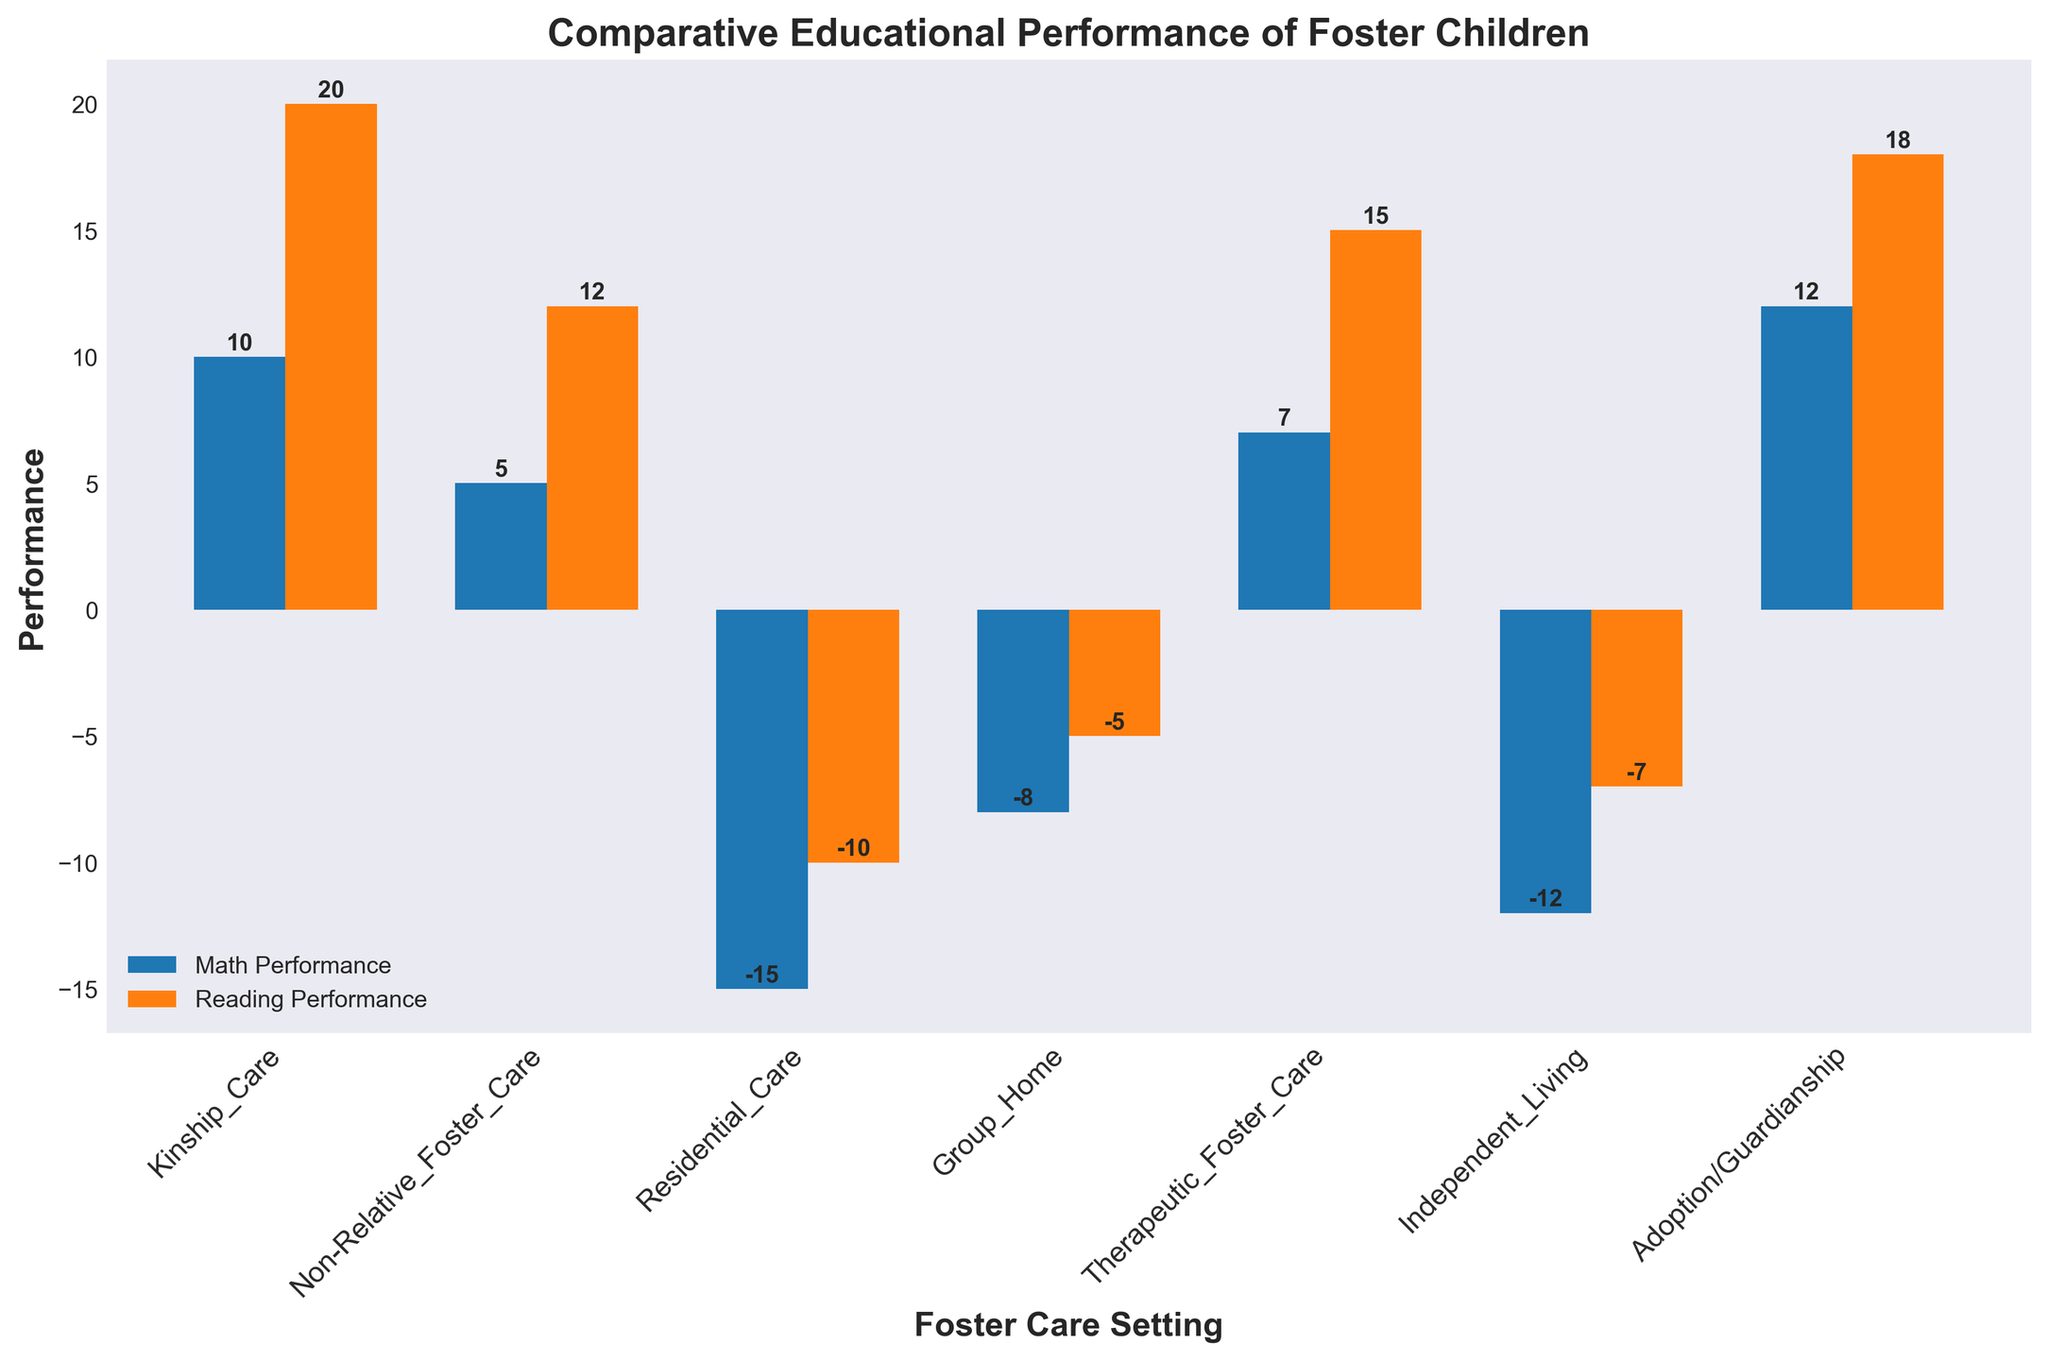What's the average Math Performance score for settings with positive values? Identify the settings with positive Math Performance (Kinship Care, Non-Relative Foster Care, Therapeutic Foster Care, and Adoption/Guardianship). Add their values: 10 + 5 + 7 + 12 = 34. Divide by the number of settings (4). The average is 34/4.
Answer: 8.5 Which foster care setting has the highest Reading Performance? Compare all the Reading Performance values. Adoption/Guardianship has the highest value at 18.
Answer: Adoption/Guardianship Which settings have negative Math Performance scores? Identify the settings with negative Math Performance: Residential Care, Group Home, and Independent Living.
Answer: Residential Care, Group Home, Independent Living How much higher is the Reading Performance in Kinship Care compared to Non-Relative Foster Care? Reading Performance in Kinship Care is 20, and 12 in Non-Relative Foster Care. The difference is 20 - 12.
Answer: 8 Is Math Performance in Group Home higher or lower compared to Non-Relative Foster Care? Compare Math Performance of Group Home (-8) and Non-Relative Foster Care (5). It is lower.
Answer: Lower What is the total Reading Performance score across all settings? Add all the Reading Performance values: 20 + 12 - 10 - 5 + 15 - 7 + 18 = 43.
Answer: 43 Which setting has the lowest Math Performance? Identify the lowest Math Performance value, which is -15 in Residential Care.
Answer: Residential Care How much lower is the Math Performance in Independent Living compared to Therapeutic Foster Care? Math Performance in Independent Living is -12, and in Therapeutic Foster Care, it is 7. The difference is 7 - (-12).
Answer: 19 Compare the Math and Reading Performance in Adoption/Guardianship. Is one higher than the other? Math Performance in Adoption/Guardianship is 12, and Reading Performance is 18. Reading Performance is higher.
Answer: Yes, Reading Performance is higher What is the average Reading Performance for settings with negative values? Identify settings with negative Reading Performance (Residential Care, Group Home, Independent Living). Add their values: -10 + (-5) + (-7) = -22. Divide by the number of settings (3). The average is -22/3.
Answer: -7.33 